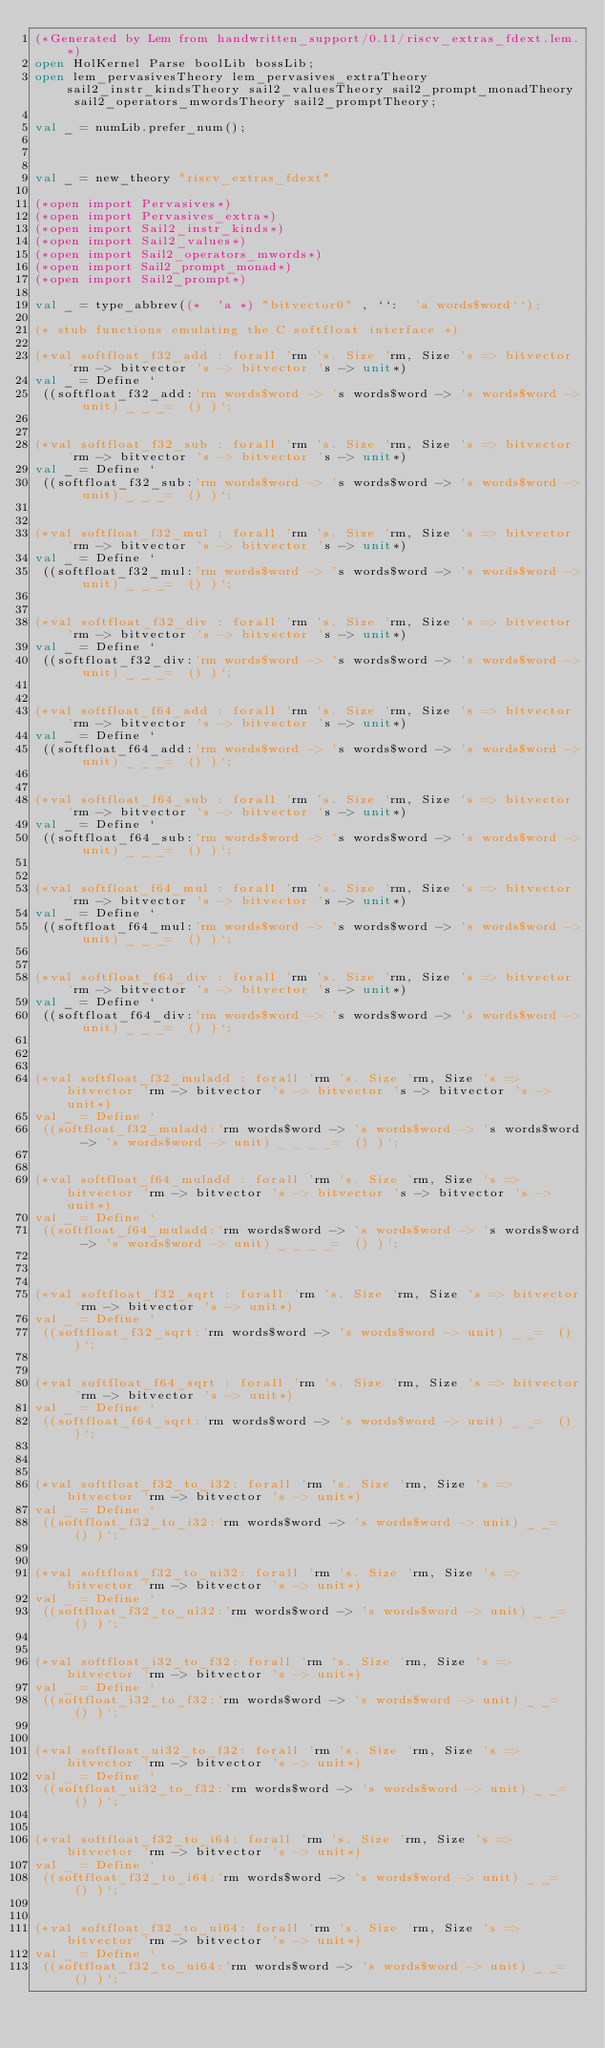Convert code to text. <code><loc_0><loc_0><loc_500><loc_500><_SML_>(*Generated by Lem from handwritten_support/0.11/riscv_extras_fdext.lem.*)
open HolKernel Parse boolLib bossLib;
open lem_pervasivesTheory lem_pervasives_extraTheory sail2_instr_kindsTheory sail2_valuesTheory sail2_prompt_monadTheory sail2_operators_mwordsTheory sail2_promptTheory;

val _ = numLib.prefer_num();



val _ = new_theory "riscv_extras_fdext"

(*open import Pervasives*)
(*open import Pervasives_extra*)
(*open import Sail2_instr_kinds*)
(*open import Sail2_values*)
(*open import Sail2_operators_mwords*)
(*open import Sail2_prompt_monad*)
(*open import Sail2_prompt*)

val _ = type_abbrev((*  'a *) "bitvector0" , ``:  'a words$word``);

(* stub functions emulating the C softfloat interface *)

(*val softfloat_f32_add : forall 'rm 's. Size 'rm, Size 's => bitvector 'rm -> bitvector 's -> bitvector 's -> unit*)
val _ = Define `
 ((softfloat_f32_add:'rm words$word -> 's words$word -> 's words$word -> unit) _ _ _=  () )`;


(*val softfloat_f32_sub : forall 'rm 's. Size 'rm, Size 's => bitvector 'rm -> bitvector 's -> bitvector 's -> unit*)
val _ = Define `
 ((softfloat_f32_sub:'rm words$word -> 's words$word -> 's words$word -> unit) _ _ _=  () )`;


(*val softfloat_f32_mul : forall 'rm 's. Size 'rm, Size 's => bitvector 'rm -> bitvector 's -> bitvector 's -> unit*)
val _ = Define `
 ((softfloat_f32_mul:'rm words$word -> 's words$word -> 's words$word -> unit) _ _ _=  () )`;


(*val softfloat_f32_div : forall 'rm 's. Size 'rm, Size 's => bitvector 'rm -> bitvector 's -> bitvector 's -> unit*)
val _ = Define `
 ((softfloat_f32_div:'rm words$word -> 's words$word -> 's words$word -> unit) _ _ _=  () )`;


(*val softfloat_f64_add : forall 'rm 's. Size 'rm, Size 's => bitvector 'rm -> bitvector 's -> bitvector 's -> unit*)
val _ = Define `
 ((softfloat_f64_add:'rm words$word -> 's words$word -> 's words$word -> unit) _ _ _=  () )`;


(*val softfloat_f64_sub : forall 'rm 's. Size 'rm, Size 's => bitvector 'rm -> bitvector 's -> bitvector 's -> unit*)
val _ = Define `
 ((softfloat_f64_sub:'rm words$word -> 's words$word -> 's words$word -> unit) _ _ _=  () )`;


(*val softfloat_f64_mul : forall 'rm 's. Size 'rm, Size 's => bitvector 'rm -> bitvector 's -> bitvector 's -> unit*)
val _ = Define `
 ((softfloat_f64_mul:'rm words$word -> 's words$word -> 's words$word -> unit) _ _ _=  () )`;


(*val softfloat_f64_div : forall 'rm 's. Size 'rm, Size 's => bitvector 'rm -> bitvector 's -> bitvector 's -> unit*)
val _ = Define `
 ((softfloat_f64_div:'rm words$word -> 's words$word -> 's words$word -> unit) _ _ _=  () )`;



(*val softfloat_f32_muladd : forall 'rm 's. Size 'rm, Size 's => bitvector 'rm -> bitvector 's -> bitvector 's -> bitvector 's -> unit*)
val _ = Define `
 ((softfloat_f32_muladd:'rm words$word -> 's words$word -> 's words$word -> 's words$word -> unit) _ _ _ _=  () )`;


(*val softfloat_f64_muladd : forall 'rm 's. Size 'rm, Size 's => bitvector 'rm -> bitvector 's -> bitvector 's -> bitvector 's -> unit*)
val _ = Define `
 ((softfloat_f64_muladd:'rm words$word -> 's words$word -> 's words$word -> 's words$word -> unit) _ _ _ _=  () )`;



(*val softfloat_f32_sqrt : forall 'rm 's. Size 'rm, Size 's => bitvector 'rm -> bitvector 's -> unit*)
val _ = Define `
 ((softfloat_f32_sqrt:'rm words$word -> 's words$word -> unit) _ _=  () )`;


(*val softfloat_f64_sqrt : forall 'rm 's. Size 'rm, Size 's => bitvector 'rm -> bitvector 's -> unit*)
val _ = Define `
 ((softfloat_f64_sqrt:'rm words$word -> 's words$word -> unit) _ _=  () )`;



(*val softfloat_f32_to_i32: forall 'rm 's. Size 'rm, Size 's => bitvector 'rm -> bitvector 's -> unit*)
val _ = Define `
 ((softfloat_f32_to_i32:'rm words$word -> 's words$word -> unit) _ _=  () )`;


(*val softfloat_f32_to_ui32: forall 'rm 's. Size 'rm, Size 's => bitvector 'rm -> bitvector 's -> unit*)
val _ = Define `
 ((softfloat_f32_to_ui32:'rm words$word -> 's words$word -> unit) _ _=  () )`;


(*val softfloat_i32_to_f32: forall 'rm 's. Size 'rm, Size 's => bitvector 'rm -> bitvector 's -> unit*)
val _ = Define `
 ((softfloat_i32_to_f32:'rm words$word -> 's words$word -> unit) _ _=  () )`;


(*val softfloat_ui32_to_f32: forall 'rm 's. Size 'rm, Size 's => bitvector 'rm -> bitvector 's -> unit*)
val _ = Define `
 ((softfloat_ui32_to_f32:'rm words$word -> 's words$word -> unit) _ _=  () )`;


(*val softfloat_f32_to_i64: forall 'rm 's. Size 'rm, Size 's => bitvector 'rm -> bitvector 's -> unit*)
val _ = Define `
 ((softfloat_f32_to_i64:'rm words$word -> 's words$word -> unit) _ _=  () )`;


(*val softfloat_f32_to_ui64: forall 'rm 's. Size 'rm, Size 's => bitvector 'rm -> bitvector 's -> unit*)
val _ = Define `
 ((softfloat_f32_to_ui64:'rm words$word -> 's words$word -> unit) _ _=  () )`;

</code> 